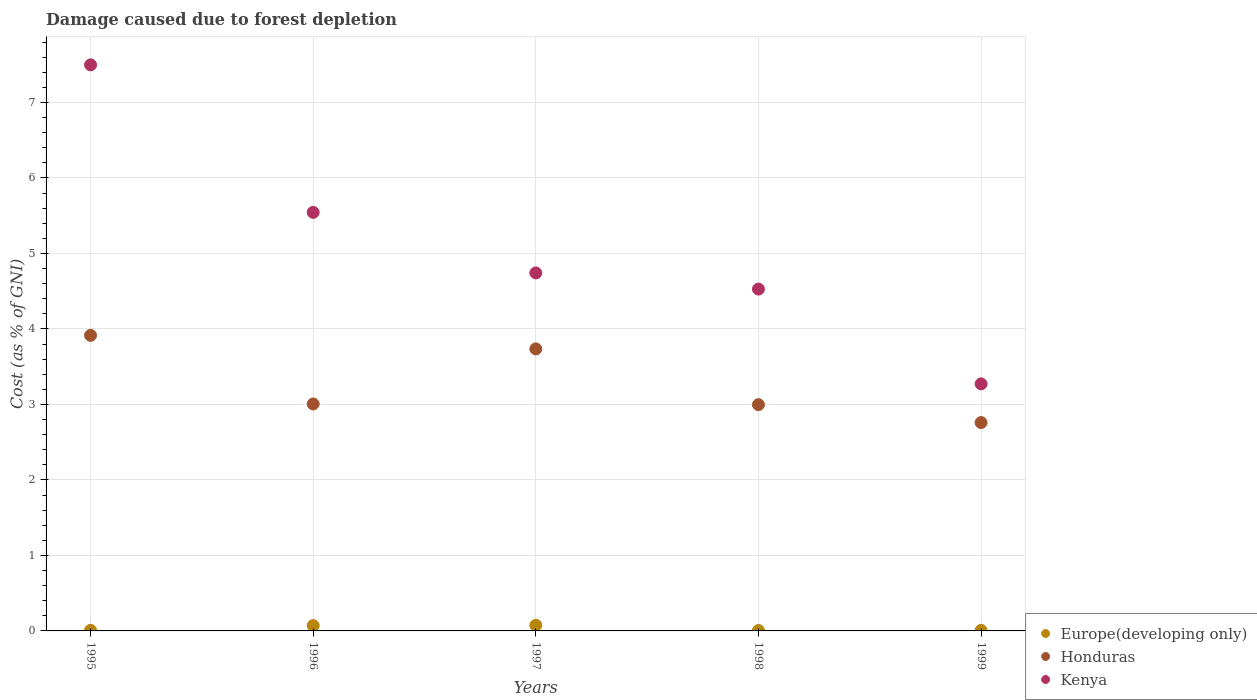How many different coloured dotlines are there?
Provide a succinct answer. 3. What is the cost of damage caused due to forest depletion in Europe(developing only) in 1995?
Give a very brief answer. 0.01. Across all years, what is the maximum cost of damage caused due to forest depletion in Honduras?
Your response must be concise. 3.91. Across all years, what is the minimum cost of damage caused due to forest depletion in Honduras?
Make the answer very short. 2.76. In which year was the cost of damage caused due to forest depletion in Kenya maximum?
Your answer should be compact. 1995. In which year was the cost of damage caused due to forest depletion in Kenya minimum?
Ensure brevity in your answer.  1999. What is the total cost of damage caused due to forest depletion in Honduras in the graph?
Your answer should be compact. 16.41. What is the difference between the cost of damage caused due to forest depletion in Europe(developing only) in 1997 and that in 1998?
Offer a terse response. 0.07. What is the difference between the cost of damage caused due to forest depletion in Europe(developing only) in 1999 and the cost of damage caused due to forest depletion in Kenya in 1996?
Provide a succinct answer. -5.54. What is the average cost of damage caused due to forest depletion in Europe(developing only) per year?
Provide a short and direct response. 0.03. In the year 1998, what is the difference between the cost of damage caused due to forest depletion in Kenya and cost of damage caused due to forest depletion in Europe(developing only)?
Offer a terse response. 4.52. In how many years, is the cost of damage caused due to forest depletion in Kenya greater than 0.2 %?
Provide a succinct answer. 5. What is the ratio of the cost of damage caused due to forest depletion in Honduras in 1995 to that in 1998?
Provide a succinct answer. 1.31. What is the difference between the highest and the second highest cost of damage caused due to forest depletion in Honduras?
Offer a terse response. 0.18. What is the difference between the highest and the lowest cost of damage caused due to forest depletion in Kenya?
Your answer should be compact. 4.23. Is the sum of the cost of damage caused due to forest depletion in Kenya in 1997 and 1999 greater than the maximum cost of damage caused due to forest depletion in Europe(developing only) across all years?
Provide a short and direct response. Yes. Does the cost of damage caused due to forest depletion in Honduras monotonically increase over the years?
Ensure brevity in your answer.  No. Is the cost of damage caused due to forest depletion in Honduras strictly less than the cost of damage caused due to forest depletion in Europe(developing only) over the years?
Your response must be concise. No. How many dotlines are there?
Make the answer very short. 3. Does the graph contain any zero values?
Offer a very short reply. No. How are the legend labels stacked?
Offer a terse response. Vertical. What is the title of the graph?
Your answer should be very brief. Damage caused due to forest depletion. What is the label or title of the X-axis?
Provide a short and direct response. Years. What is the label or title of the Y-axis?
Offer a terse response. Cost (as % of GNI). What is the Cost (as % of GNI) in Europe(developing only) in 1995?
Offer a very short reply. 0.01. What is the Cost (as % of GNI) of Honduras in 1995?
Give a very brief answer. 3.91. What is the Cost (as % of GNI) of Kenya in 1995?
Keep it short and to the point. 7.5. What is the Cost (as % of GNI) of Europe(developing only) in 1996?
Your answer should be very brief. 0.07. What is the Cost (as % of GNI) of Honduras in 1996?
Offer a terse response. 3.01. What is the Cost (as % of GNI) of Kenya in 1996?
Provide a succinct answer. 5.54. What is the Cost (as % of GNI) of Europe(developing only) in 1997?
Offer a terse response. 0.07. What is the Cost (as % of GNI) of Honduras in 1997?
Your answer should be compact. 3.74. What is the Cost (as % of GNI) of Kenya in 1997?
Give a very brief answer. 4.74. What is the Cost (as % of GNI) in Europe(developing only) in 1998?
Provide a succinct answer. 0.01. What is the Cost (as % of GNI) of Honduras in 1998?
Make the answer very short. 3. What is the Cost (as % of GNI) of Kenya in 1998?
Make the answer very short. 4.53. What is the Cost (as % of GNI) of Europe(developing only) in 1999?
Provide a short and direct response. 0.01. What is the Cost (as % of GNI) of Honduras in 1999?
Provide a short and direct response. 2.76. What is the Cost (as % of GNI) of Kenya in 1999?
Offer a very short reply. 3.27. Across all years, what is the maximum Cost (as % of GNI) in Europe(developing only)?
Your response must be concise. 0.07. Across all years, what is the maximum Cost (as % of GNI) of Honduras?
Make the answer very short. 3.91. Across all years, what is the maximum Cost (as % of GNI) of Kenya?
Provide a succinct answer. 7.5. Across all years, what is the minimum Cost (as % of GNI) of Europe(developing only)?
Your answer should be very brief. 0.01. Across all years, what is the minimum Cost (as % of GNI) of Honduras?
Ensure brevity in your answer.  2.76. Across all years, what is the minimum Cost (as % of GNI) of Kenya?
Provide a short and direct response. 3.27. What is the total Cost (as % of GNI) in Europe(developing only) in the graph?
Your answer should be very brief. 0.17. What is the total Cost (as % of GNI) in Honduras in the graph?
Offer a terse response. 16.41. What is the total Cost (as % of GNI) of Kenya in the graph?
Provide a short and direct response. 25.58. What is the difference between the Cost (as % of GNI) in Europe(developing only) in 1995 and that in 1996?
Ensure brevity in your answer.  -0.06. What is the difference between the Cost (as % of GNI) in Honduras in 1995 and that in 1996?
Your response must be concise. 0.91. What is the difference between the Cost (as % of GNI) of Kenya in 1995 and that in 1996?
Provide a short and direct response. 1.95. What is the difference between the Cost (as % of GNI) of Europe(developing only) in 1995 and that in 1997?
Make the answer very short. -0.07. What is the difference between the Cost (as % of GNI) of Honduras in 1995 and that in 1997?
Make the answer very short. 0.18. What is the difference between the Cost (as % of GNI) of Kenya in 1995 and that in 1997?
Your answer should be compact. 2.76. What is the difference between the Cost (as % of GNI) in Europe(developing only) in 1995 and that in 1998?
Your response must be concise. 0. What is the difference between the Cost (as % of GNI) of Honduras in 1995 and that in 1998?
Your answer should be very brief. 0.92. What is the difference between the Cost (as % of GNI) in Kenya in 1995 and that in 1998?
Provide a succinct answer. 2.97. What is the difference between the Cost (as % of GNI) of Europe(developing only) in 1995 and that in 1999?
Keep it short and to the point. 0. What is the difference between the Cost (as % of GNI) of Honduras in 1995 and that in 1999?
Provide a succinct answer. 1.16. What is the difference between the Cost (as % of GNI) in Kenya in 1995 and that in 1999?
Give a very brief answer. 4.23. What is the difference between the Cost (as % of GNI) in Europe(developing only) in 1996 and that in 1997?
Your response must be concise. -0. What is the difference between the Cost (as % of GNI) in Honduras in 1996 and that in 1997?
Offer a terse response. -0.73. What is the difference between the Cost (as % of GNI) in Kenya in 1996 and that in 1997?
Make the answer very short. 0.8. What is the difference between the Cost (as % of GNI) in Europe(developing only) in 1996 and that in 1998?
Give a very brief answer. 0.07. What is the difference between the Cost (as % of GNI) in Honduras in 1996 and that in 1998?
Keep it short and to the point. 0.01. What is the difference between the Cost (as % of GNI) of Kenya in 1996 and that in 1998?
Your answer should be very brief. 1.02. What is the difference between the Cost (as % of GNI) of Europe(developing only) in 1996 and that in 1999?
Keep it short and to the point. 0.06. What is the difference between the Cost (as % of GNI) of Honduras in 1996 and that in 1999?
Keep it short and to the point. 0.25. What is the difference between the Cost (as % of GNI) of Kenya in 1996 and that in 1999?
Offer a terse response. 2.27. What is the difference between the Cost (as % of GNI) of Europe(developing only) in 1997 and that in 1998?
Offer a very short reply. 0.07. What is the difference between the Cost (as % of GNI) in Honduras in 1997 and that in 1998?
Provide a succinct answer. 0.74. What is the difference between the Cost (as % of GNI) of Kenya in 1997 and that in 1998?
Your answer should be compact. 0.21. What is the difference between the Cost (as % of GNI) of Europe(developing only) in 1997 and that in 1999?
Your answer should be very brief. 0.07. What is the difference between the Cost (as % of GNI) of Honduras in 1997 and that in 1999?
Your response must be concise. 0.98. What is the difference between the Cost (as % of GNI) of Kenya in 1997 and that in 1999?
Provide a short and direct response. 1.47. What is the difference between the Cost (as % of GNI) of Europe(developing only) in 1998 and that in 1999?
Offer a terse response. -0. What is the difference between the Cost (as % of GNI) of Honduras in 1998 and that in 1999?
Your answer should be very brief. 0.24. What is the difference between the Cost (as % of GNI) in Kenya in 1998 and that in 1999?
Your answer should be very brief. 1.26. What is the difference between the Cost (as % of GNI) of Europe(developing only) in 1995 and the Cost (as % of GNI) of Honduras in 1996?
Give a very brief answer. -3. What is the difference between the Cost (as % of GNI) of Europe(developing only) in 1995 and the Cost (as % of GNI) of Kenya in 1996?
Offer a very short reply. -5.54. What is the difference between the Cost (as % of GNI) in Honduras in 1995 and the Cost (as % of GNI) in Kenya in 1996?
Offer a terse response. -1.63. What is the difference between the Cost (as % of GNI) of Europe(developing only) in 1995 and the Cost (as % of GNI) of Honduras in 1997?
Provide a short and direct response. -3.73. What is the difference between the Cost (as % of GNI) in Europe(developing only) in 1995 and the Cost (as % of GNI) in Kenya in 1997?
Your answer should be very brief. -4.73. What is the difference between the Cost (as % of GNI) of Honduras in 1995 and the Cost (as % of GNI) of Kenya in 1997?
Ensure brevity in your answer.  -0.83. What is the difference between the Cost (as % of GNI) in Europe(developing only) in 1995 and the Cost (as % of GNI) in Honduras in 1998?
Provide a succinct answer. -2.99. What is the difference between the Cost (as % of GNI) of Europe(developing only) in 1995 and the Cost (as % of GNI) of Kenya in 1998?
Make the answer very short. -4.52. What is the difference between the Cost (as % of GNI) in Honduras in 1995 and the Cost (as % of GNI) in Kenya in 1998?
Keep it short and to the point. -0.61. What is the difference between the Cost (as % of GNI) of Europe(developing only) in 1995 and the Cost (as % of GNI) of Honduras in 1999?
Ensure brevity in your answer.  -2.75. What is the difference between the Cost (as % of GNI) in Europe(developing only) in 1995 and the Cost (as % of GNI) in Kenya in 1999?
Keep it short and to the point. -3.26. What is the difference between the Cost (as % of GNI) in Honduras in 1995 and the Cost (as % of GNI) in Kenya in 1999?
Provide a short and direct response. 0.64. What is the difference between the Cost (as % of GNI) of Europe(developing only) in 1996 and the Cost (as % of GNI) of Honduras in 1997?
Make the answer very short. -3.66. What is the difference between the Cost (as % of GNI) in Europe(developing only) in 1996 and the Cost (as % of GNI) in Kenya in 1997?
Offer a very short reply. -4.67. What is the difference between the Cost (as % of GNI) of Honduras in 1996 and the Cost (as % of GNI) of Kenya in 1997?
Offer a terse response. -1.74. What is the difference between the Cost (as % of GNI) in Europe(developing only) in 1996 and the Cost (as % of GNI) in Honduras in 1998?
Your response must be concise. -2.93. What is the difference between the Cost (as % of GNI) of Europe(developing only) in 1996 and the Cost (as % of GNI) of Kenya in 1998?
Ensure brevity in your answer.  -4.46. What is the difference between the Cost (as % of GNI) of Honduras in 1996 and the Cost (as % of GNI) of Kenya in 1998?
Offer a very short reply. -1.52. What is the difference between the Cost (as % of GNI) in Europe(developing only) in 1996 and the Cost (as % of GNI) in Honduras in 1999?
Offer a terse response. -2.69. What is the difference between the Cost (as % of GNI) of Europe(developing only) in 1996 and the Cost (as % of GNI) of Kenya in 1999?
Ensure brevity in your answer.  -3.2. What is the difference between the Cost (as % of GNI) of Honduras in 1996 and the Cost (as % of GNI) of Kenya in 1999?
Offer a very short reply. -0.27. What is the difference between the Cost (as % of GNI) of Europe(developing only) in 1997 and the Cost (as % of GNI) of Honduras in 1998?
Provide a short and direct response. -2.92. What is the difference between the Cost (as % of GNI) in Europe(developing only) in 1997 and the Cost (as % of GNI) in Kenya in 1998?
Your response must be concise. -4.45. What is the difference between the Cost (as % of GNI) of Honduras in 1997 and the Cost (as % of GNI) of Kenya in 1998?
Provide a succinct answer. -0.79. What is the difference between the Cost (as % of GNI) in Europe(developing only) in 1997 and the Cost (as % of GNI) in Honduras in 1999?
Make the answer very short. -2.68. What is the difference between the Cost (as % of GNI) in Europe(developing only) in 1997 and the Cost (as % of GNI) in Kenya in 1999?
Ensure brevity in your answer.  -3.2. What is the difference between the Cost (as % of GNI) of Honduras in 1997 and the Cost (as % of GNI) of Kenya in 1999?
Provide a short and direct response. 0.46. What is the difference between the Cost (as % of GNI) in Europe(developing only) in 1998 and the Cost (as % of GNI) in Honduras in 1999?
Make the answer very short. -2.75. What is the difference between the Cost (as % of GNI) in Europe(developing only) in 1998 and the Cost (as % of GNI) in Kenya in 1999?
Your response must be concise. -3.27. What is the difference between the Cost (as % of GNI) of Honduras in 1998 and the Cost (as % of GNI) of Kenya in 1999?
Your answer should be very brief. -0.28. What is the average Cost (as % of GNI) in Europe(developing only) per year?
Make the answer very short. 0.03. What is the average Cost (as % of GNI) of Honduras per year?
Offer a very short reply. 3.28. What is the average Cost (as % of GNI) of Kenya per year?
Offer a very short reply. 5.12. In the year 1995, what is the difference between the Cost (as % of GNI) in Europe(developing only) and Cost (as % of GNI) in Honduras?
Offer a terse response. -3.91. In the year 1995, what is the difference between the Cost (as % of GNI) of Europe(developing only) and Cost (as % of GNI) of Kenya?
Provide a succinct answer. -7.49. In the year 1995, what is the difference between the Cost (as % of GNI) in Honduras and Cost (as % of GNI) in Kenya?
Provide a short and direct response. -3.58. In the year 1996, what is the difference between the Cost (as % of GNI) of Europe(developing only) and Cost (as % of GNI) of Honduras?
Offer a very short reply. -2.94. In the year 1996, what is the difference between the Cost (as % of GNI) of Europe(developing only) and Cost (as % of GNI) of Kenya?
Your answer should be compact. -5.47. In the year 1996, what is the difference between the Cost (as % of GNI) in Honduras and Cost (as % of GNI) in Kenya?
Your answer should be compact. -2.54. In the year 1997, what is the difference between the Cost (as % of GNI) of Europe(developing only) and Cost (as % of GNI) of Honduras?
Provide a succinct answer. -3.66. In the year 1997, what is the difference between the Cost (as % of GNI) in Europe(developing only) and Cost (as % of GNI) in Kenya?
Provide a succinct answer. -4.67. In the year 1997, what is the difference between the Cost (as % of GNI) in Honduras and Cost (as % of GNI) in Kenya?
Give a very brief answer. -1.01. In the year 1998, what is the difference between the Cost (as % of GNI) in Europe(developing only) and Cost (as % of GNI) in Honduras?
Ensure brevity in your answer.  -2.99. In the year 1998, what is the difference between the Cost (as % of GNI) in Europe(developing only) and Cost (as % of GNI) in Kenya?
Keep it short and to the point. -4.52. In the year 1998, what is the difference between the Cost (as % of GNI) of Honduras and Cost (as % of GNI) of Kenya?
Give a very brief answer. -1.53. In the year 1999, what is the difference between the Cost (as % of GNI) in Europe(developing only) and Cost (as % of GNI) in Honduras?
Offer a terse response. -2.75. In the year 1999, what is the difference between the Cost (as % of GNI) in Europe(developing only) and Cost (as % of GNI) in Kenya?
Your answer should be compact. -3.27. In the year 1999, what is the difference between the Cost (as % of GNI) of Honduras and Cost (as % of GNI) of Kenya?
Provide a succinct answer. -0.51. What is the ratio of the Cost (as % of GNI) of Europe(developing only) in 1995 to that in 1996?
Ensure brevity in your answer.  0.11. What is the ratio of the Cost (as % of GNI) of Honduras in 1995 to that in 1996?
Your answer should be very brief. 1.3. What is the ratio of the Cost (as % of GNI) in Kenya in 1995 to that in 1996?
Your response must be concise. 1.35. What is the ratio of the Cost (as % of GNI) in Europe(developing only) in 1995 to that in 1997?
Offer a terse response. 0.11. What is the ratio of the Cost (as % of GNI) in Honduras in 1995 to that in 1997?
Your response must be concise. 1.05. What is the ratio of the Cost (as % of GNI) of Kenya in 1995 to that in 1997?
Keep it short and to the point. 1.58. What is the ratio of the Cost (as % of GNI) of Europe(developing only) in 1995 to that in 1998?
Offer a terse response. 1.47. What is the ratio of the Cost (as % of GNI) in Honduras in 1995 to that in 1998?
Provide a short and direct response. 1.31. What is the ratio of the Cost (as % of GNI) in Kenya in 1995 to that in 1998?
Make the answer very short. 1.66. What is the ratio of the Cost (as % of GNI) of Europe(developing only) in 1995 to that in 1999?
Give a very brief answer. 1.17. What is the ratio of the Cost (as % of GNI) in Honduras in 1995 to that in 1999?
Give a very brief answer. 1.42. What is the ratio of the Cost (as % of GNI) in Kenya in 1995 to that in 1999?
Offer a very short reply. 2.29. What is the ratio of the Cost (as % of GNI) in Europe(developing only) in 1996 to that in 1997?
Your answer should be very brief. 0.95. What is the ratio of the Cost (as % of GNI) of Honduras in 1996 to that in 1997?
Provide a succinct answer. 0.8. What is the ratio of the Cost (as % of GNI) in Kenya in 1996 to that in 1997?
Give a very brief answer. 1.17. What is the ratio of the Cost (as % of GNI) of Europe(developing only) in 1996 to that in 1998?
Offer a terse response. 13.11. What is the ratio of the Cost (as % of GNI) in Honduras in 1996 to that in 1998?
Give a very brief answer. 1. What is the ratio of the Cost (as % of GNI) of Kenya in 1996 to that in 1998?
Ensure brevity in your answer.  1.22. What is the ratio of the Cost (as % of GNI) of Europe(developing only) in 1996 to that in 1999?
Give a very brief answer. 10.37. What is the ratio of the Cost (as % of GNI) in Honduras in 1996 to that in 1999?
Keep it short and to the point. 1.09. What is the ratio of the Cost (as % of GNI) of Kenya in 1996 to that in 1999?
Your answer should be compact. 1.69. What is the ratio of the Cost (as % of GNI) in Europe(developing only) in 1997 to that in 1998?
Your response must be concise. 13.76. What is the ratio of the Cost (as % of GNI) of Honduras in 1997 to that in 1998?
Offer a terse response. 1.25. What is the ratio of the Cost (as % of GNI) in Kenya in 1997 to that in 1998?
Ensure brevity in your answer.  1.05. What is the ratio of the Cost (as % of GNI) in Europe(developing only) in 1997 to that in 1999?
Offer a terse response. 10.88. What is the ratio of the Cost (as % of GNI) of Honduras in 1997 to that in 1999?
Give a very brief answer. 1.35. What is the ratio of the Cost (as % of GNI) of Kenya in 1997 to that in 1999?
Offer a very short reply. 1.45. What is the ratio of the Cost (as % of GNI) in Europe(developing only) in 1998 to that in 1999?
Provide a succinct answer. 0.79. What is the ratio of the Cost (as % of GNI) of Honduras in 1998 to that in 1999?
Your answer should be very brief. 1.09. What is the ratio of the Cost (as % of GNI) of Kenya in 1998 to that in 1999?
Your response must be concise. 1.38. What is the difference between the highest and the second highest Cost (as % of GNI) of Europe(developing only)?
Provide a succinct answer. 0. What is the difference between the highest and the second highest Cost (as % of GNI) in Honduras?
Make the answer very short. 0.18. What is the difference between the highest and the second highest Cost (as % of GNI) in Kenya?
Offer a terse response. 1.95. What is the difference between the highest and the lowest Cost (as % of GNI) of Europe(developing only)?
Offer a terse response. 0.07. What is the difference between the highest and the lowest Cost (as % of GNI) of Honduras?
Make the answer very short. 1.16. What is the difference between the highest and the lowest Cost (as % of GNI) of Kenya?
Give a very brief answer. 4.23. 